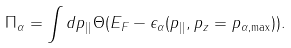<formula> <loc_0><loc_0><loc_500><loc_500>\Pi _ { \alpha } = \int d { p } _ { | | } \Theta ( E _ { F } - \epsilon _ { \alpha } ( { p } _ { | | } , p _ { z } = p _ { \alpha , \max } ) ) .</formula> 